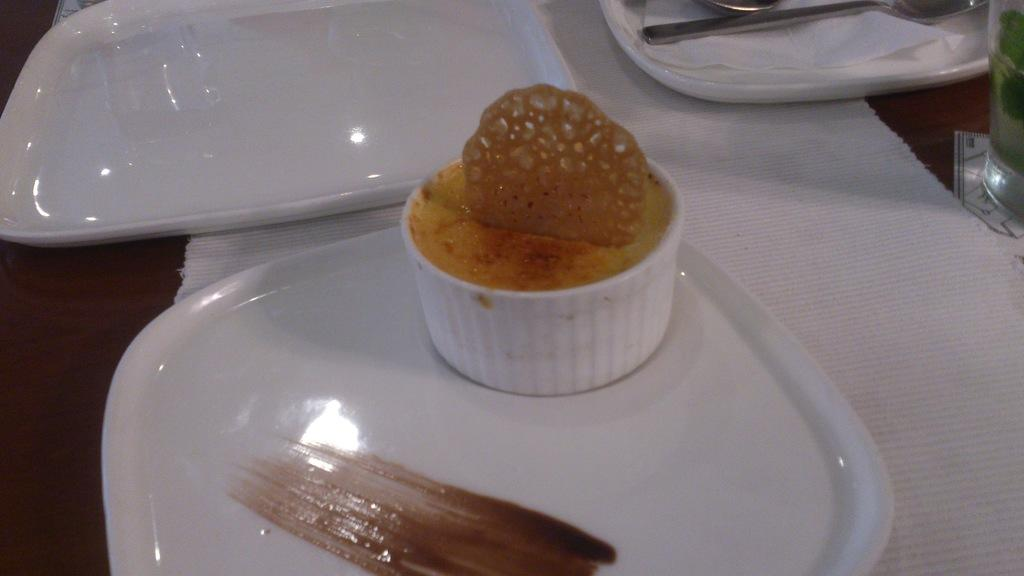What is on the plate that is visible in the image? There is a cupcake on a plate in the image. How many plates can be seen in the image? There are multiple plates in the image. What utensils are visible in the image? Spoons are visible in the image. What is covering the table in the image? There is a tablecloth on the table in the image. How does the ocean contribute to the comfort of the table setting in the image? The image does not depict an ocean, nor does it show any elements related to comfort or relaxation. 